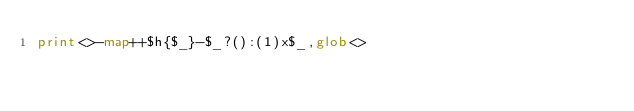<code> <loc_0><loc_0><loc_500><loc_500><_Perl_>print<>-map++$h{$_}-$_?():(1)x$_,glob<></code> 